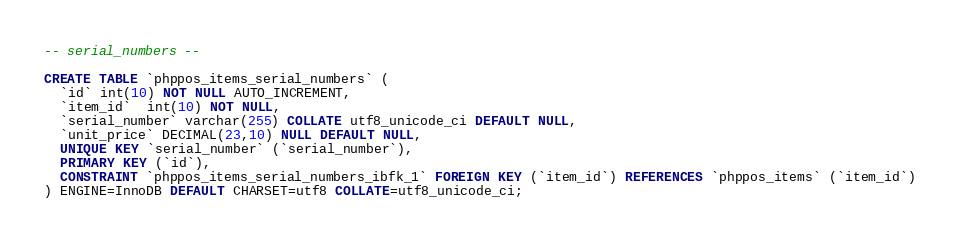<code> <loc_0><loc_0><loc_500><loc_500><_SQL_>-- serial_numbers --

CREATE TABLE `phppos_items_serial_numbers` (
  `id` int(10) NOT NULL AUTO_INCREMENT,
  `item_id`  int(10) NOT NULL,
  `serial_number` varchar(255) COLLATE utf8_unicode_ci DEFAULT NULL,
  `unit_price` DECIMAL(23,10) NULL DEFAULT NULL,
  UNIQUE KEY `serial_number` (`serial_number`),
  PRIMARY KEY (`id`),
  CONSTRAINT `phppos_items_serial_numbers_ibfk_1` FOREIGN KEY (`item_id`) REFERENCES `phppos_items` (`item_id`)
) ENGINE=InnoDB DEFAULT CHARSET=utf8 COLLATE=utf8_unicode_ci;
</code> 